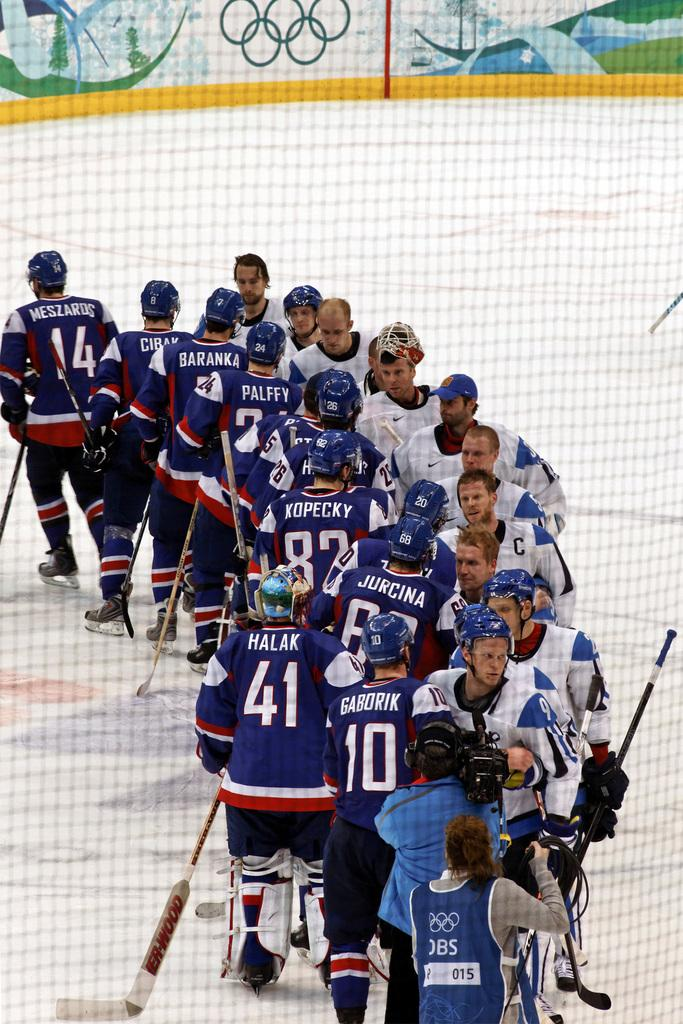<image>
Share a concise interpretation of the image provided. One of the guys on the hock team is named Halak and he wears the number 41. 